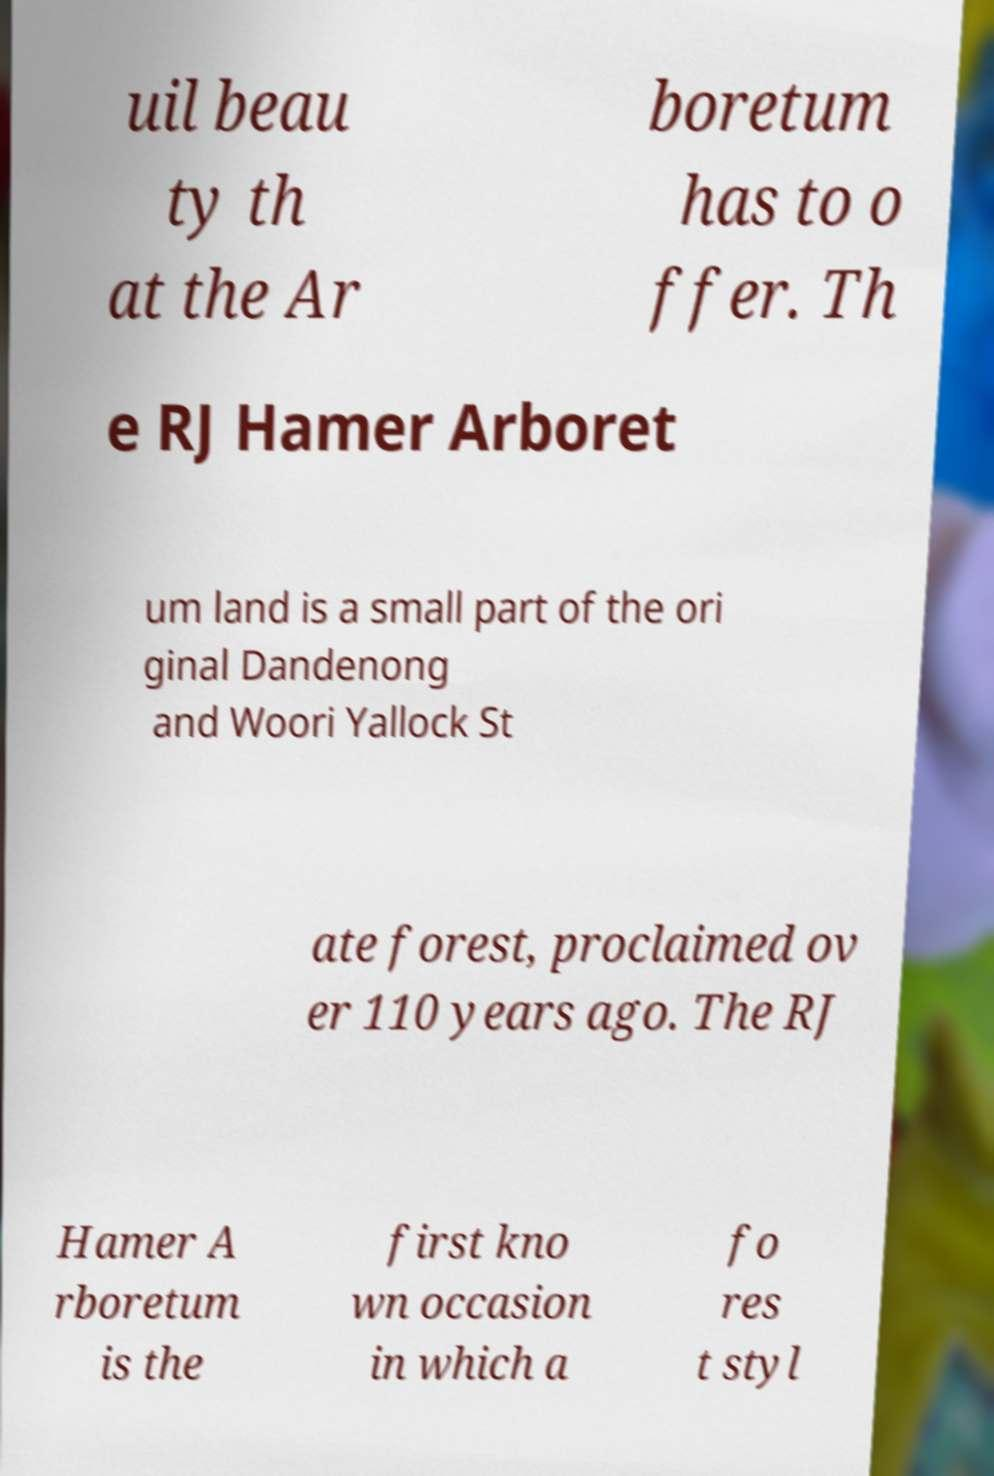I need the written content from this picture converted into text. Can you do that? uil beau ty th at the Ar boretum has to o ffer. Th e RJ Hamer Arboret um land is a small part of the ori ginal Dandenong and Woori Yallock St ate forest, proclaimed ov er 110 years ago. The RJ Hamer A rboretum is the first kno wn occasion in which a fo res t styl 